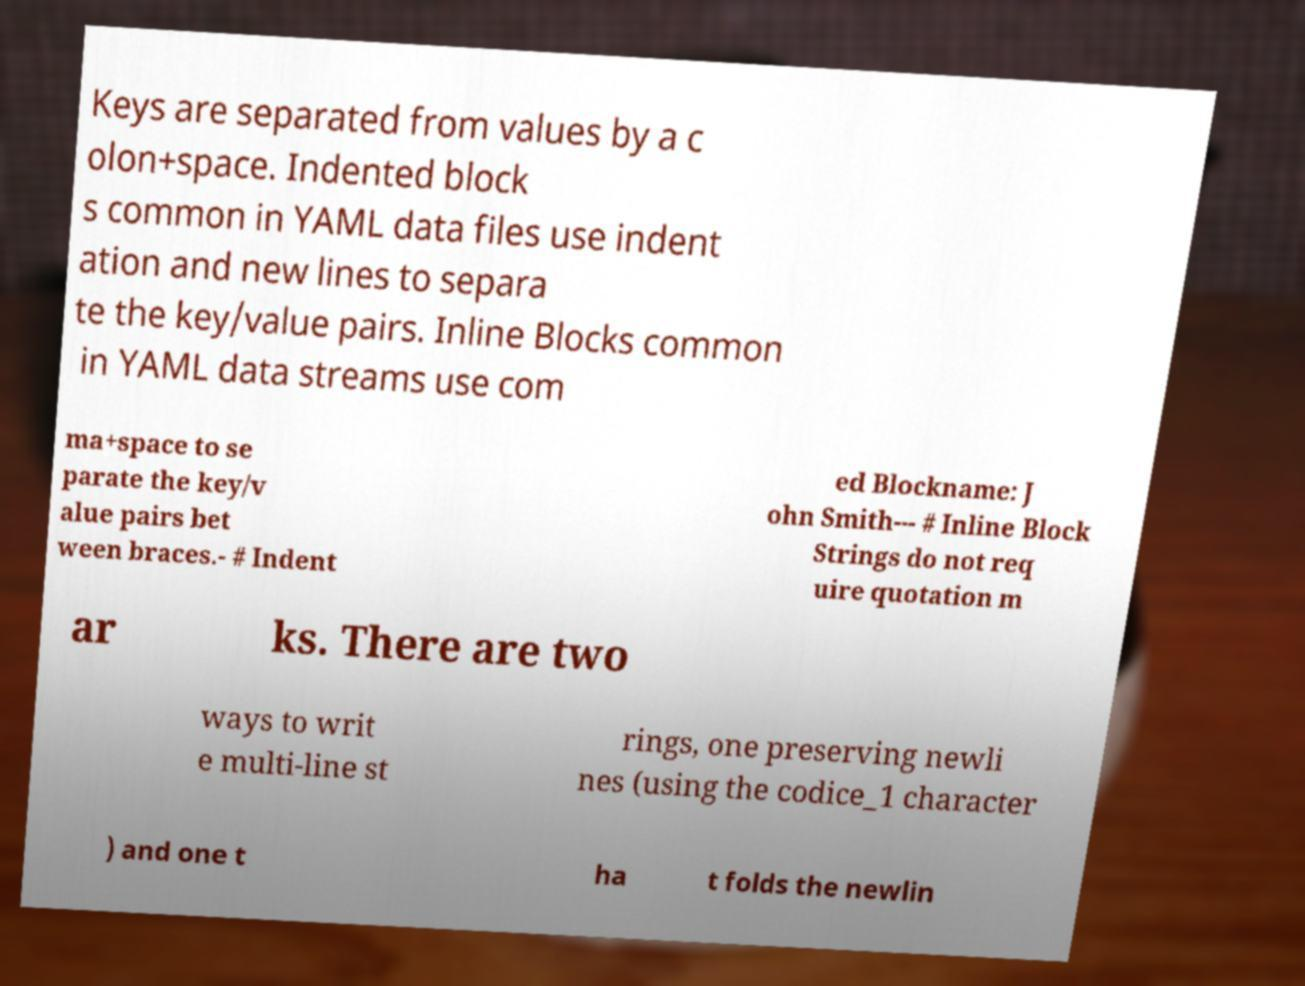Could you assist in decoding the text presented in this image and type it out clearly? Keys are separated from values by a c olon+space. Indented block s common in YAML data files use indent ation and new lines to separa te the key/value pairs. Inline Blocks common in YAML data streams use com ma+space to se parate the key/v alue pairs bet ween braces.- # Indent ed Blockname: J ohn Smith--- # Inline Block Strings do not req uire quotation m ar ks. There are two ways to writ e multi-line st rings, one preserving newli nes (using the codice_1 character ) and one t ha t folds the newlin 